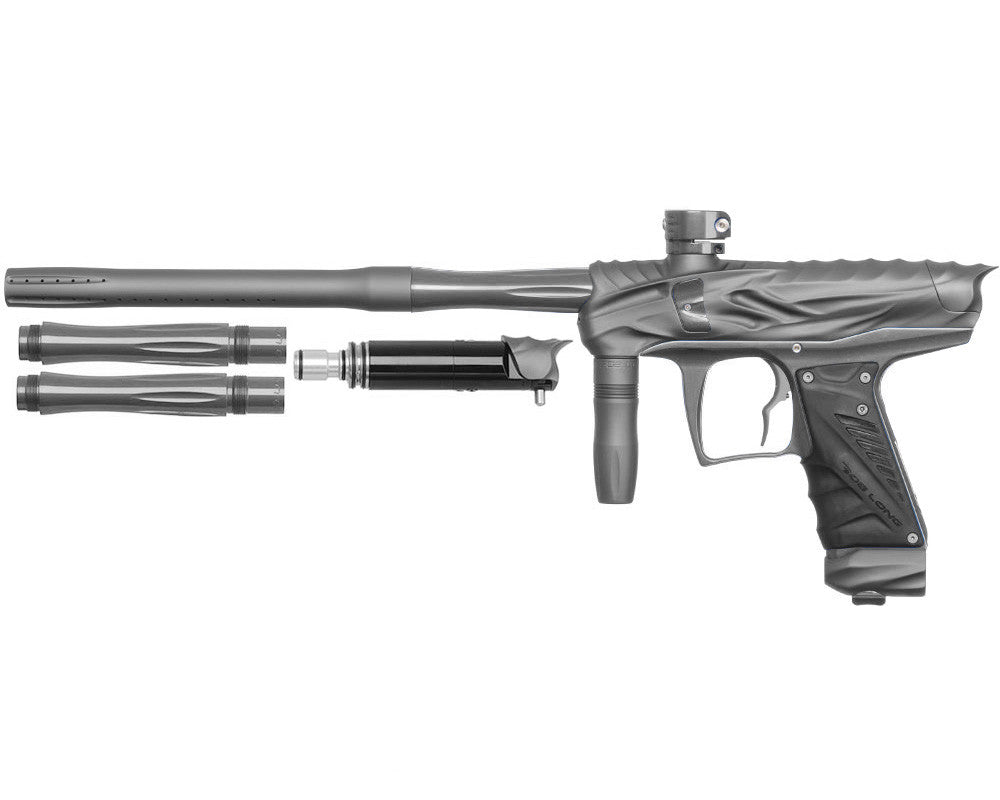Taking into account the design and modularity of this paintball gun, what might be the primary purpose of the venting on the additional barrel pieces? The venting on the additional barrel pieces of a paintball gun serves several crucial functions. Primarily, it helps reduce the noise produced during firing, which can be essential for stealth in competitive play. Furthermore, the vents manage the air pressure released upon firing, which is pivotal for maintaining a consistent velocity of paintballs. This contribution to stability and pressure management not only refines the gun's accuracy but also enhances overall shooting performance, ensuring that players can fire more effectively and precisely. 